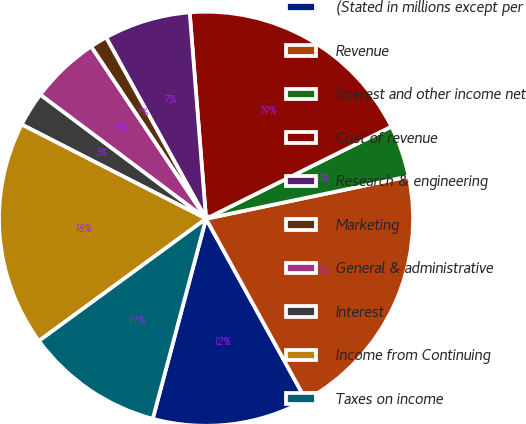<chart> <loc_0><loc_0><loc_500><loc_500><pie_chart><fcel>(Stated in millions except per<fcel>Revenue<fcel>Interest and other income net<fcel>Cost of revenue<fcel>Research & engineering<fcel>Marketing<fcel>General & administrative<fcel>Interest<fcel>Income from Continuing<fcel>Taxes on income<nl><fcel>12.16%<fcel>20.27%<fcel>4.06%<fcel>18.92%<fcel>6.76%<fcel>1.35%<fcel>5.41%<fcel>2.7%<fcel>17.57%<fcel>10.81%<nl></chart> 